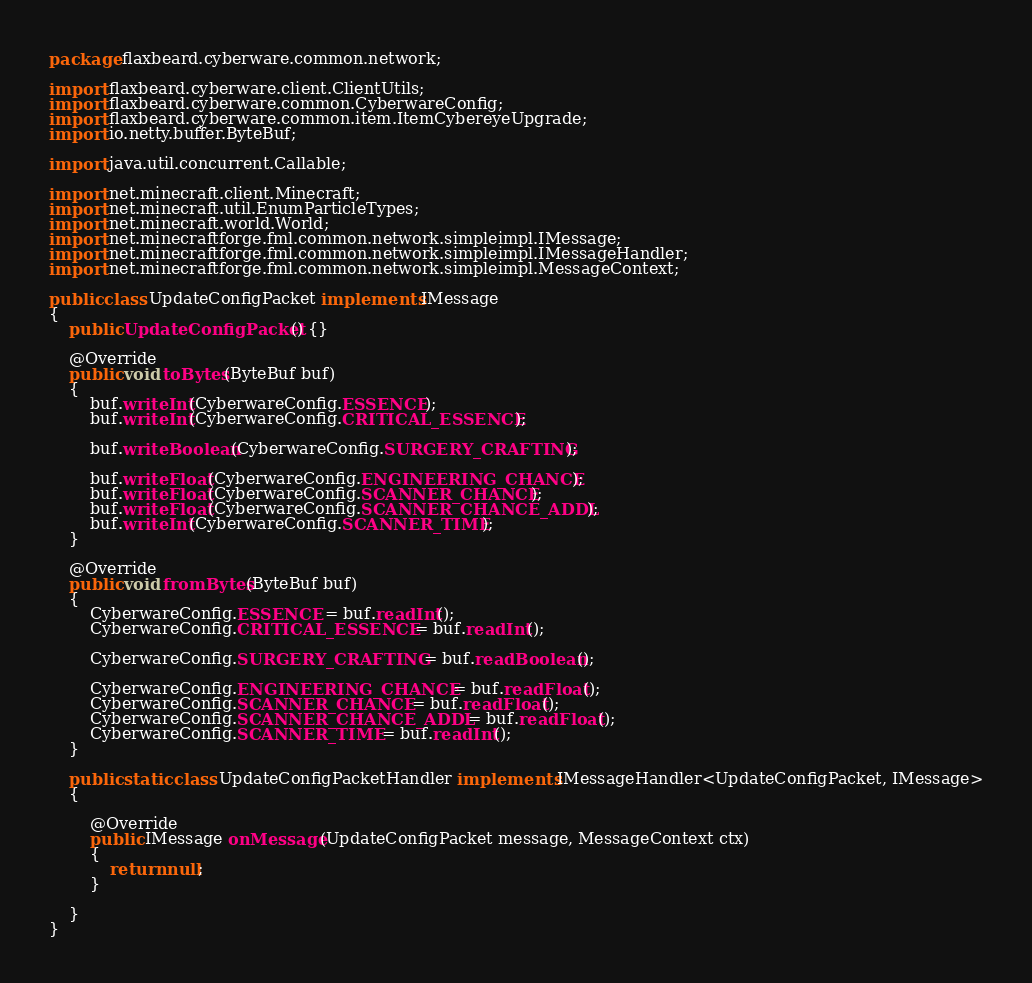<code> <loc_0><loc_0><loc_500><loc_500><_Java_>package flaxbeard.cyberware.common.network;

import flaxbeard.cyberware.client.ClientUtils;
import flaxbeard.cyberware.common.CyberwareConfig;
import flaxbeard.cyberware.common.item.ItemCybereyeUpgrade;
import io.netty.buffer.ByteBuf;

import java.util.concurrent.Callable;

import net.minecraft.client.Minecraft;
import net.minecraft.util.EnumParticleTypes;
import net.minecraft.world.World;
import net.minecraftforge.fml.common.network.simpleimpl.IMessage;
import net.minecraftforge.fml.common.network.simpleimpl.IMessageHandler;
import net.minecraftforge.fml.common.network.simpleimpl.MessageContext;

public class UpdateConfigPacket implements IMessage
{
	public UpdateConfigPacket() {}

	@Override
	public void toBytes(ByteBuf buf)
	{
		buf.writeInt(CyberwareConfig.ESSENCE);
		buf.writeInt(CyberwareConfig.CRITICAL_ESSENCE);
		
		buf.writeBoolean(CyberwareConfig.SURGERY_CRAFTING);
		
		buf.writeFloat(CyberwareConfig.ENGINEERING_CHANCE);
		buf.writeFloat(CyberwareConfig.SCANNER_CHANCE);
		buf.writeFloat(CyberwareConfig.SCANNER_CHANCE_ADDL);
		buf.writeInt(CyberwareConfig.SCANNER_TIME);
	}
	
	@Override
	public void fromBytes(ByteBuf buf)
	{
		CyberwareConfig.ESSENCE = buf.readInt();
		CyberwareConfig.CRITICAL_ESSENCE = buf.readInt();
		
		CyberwareConfig.SURGERY_CRAFTING = buf.readBoolean();
		
		CyberwareConfig.ENGINEERING_CHANCE = buf.readFloat();
		CyberwareConfig.SCANNER_CHANCE = buf.readFloat();
		CyberwareConfig.SCANNER_CHANCE_ADDL = buf.readFloat();
		CyberwareConfig.SCANNER_TIME = buf.readInt();
	}
	
	public static class UpdateConfigPacketHandler implements IMessageHandler<UpdateConfigPacket, IMessage>
	{

		@Override
		public IMessage onMessage(UpdateConfigPacket message, MessageContext ctx)
		{
			return null;
		}
		
	}
}
</code> 